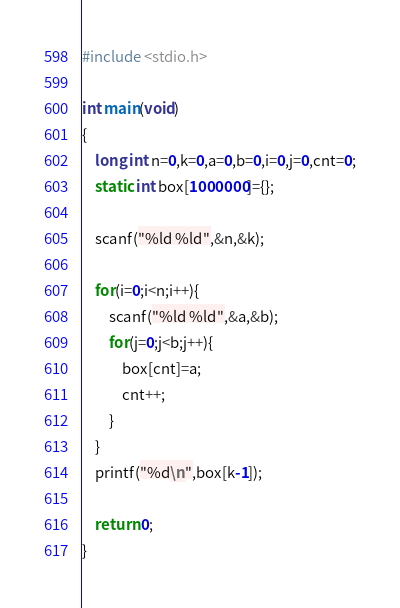<code> <loc_0><loc_0><loc_500><loc_500><_C_>#include <stdio.h>

int main(void)
{
    long int n=0,k=0,a=0,b=0,i=0,j=0,cnt=0;
    static int box[1000000]={};
    
    scanf("%ld %ld",&n,&k);
    
    for(i=0;i<n;i++){
        scanf("%ld %ld",&a,&b);
        for(j=0;j<b;j++){
            box[cnt]=a;
            cnt++;
        }
    }
    printf("%d\n",box[k-1]);
    
    return 0;
}</code> 